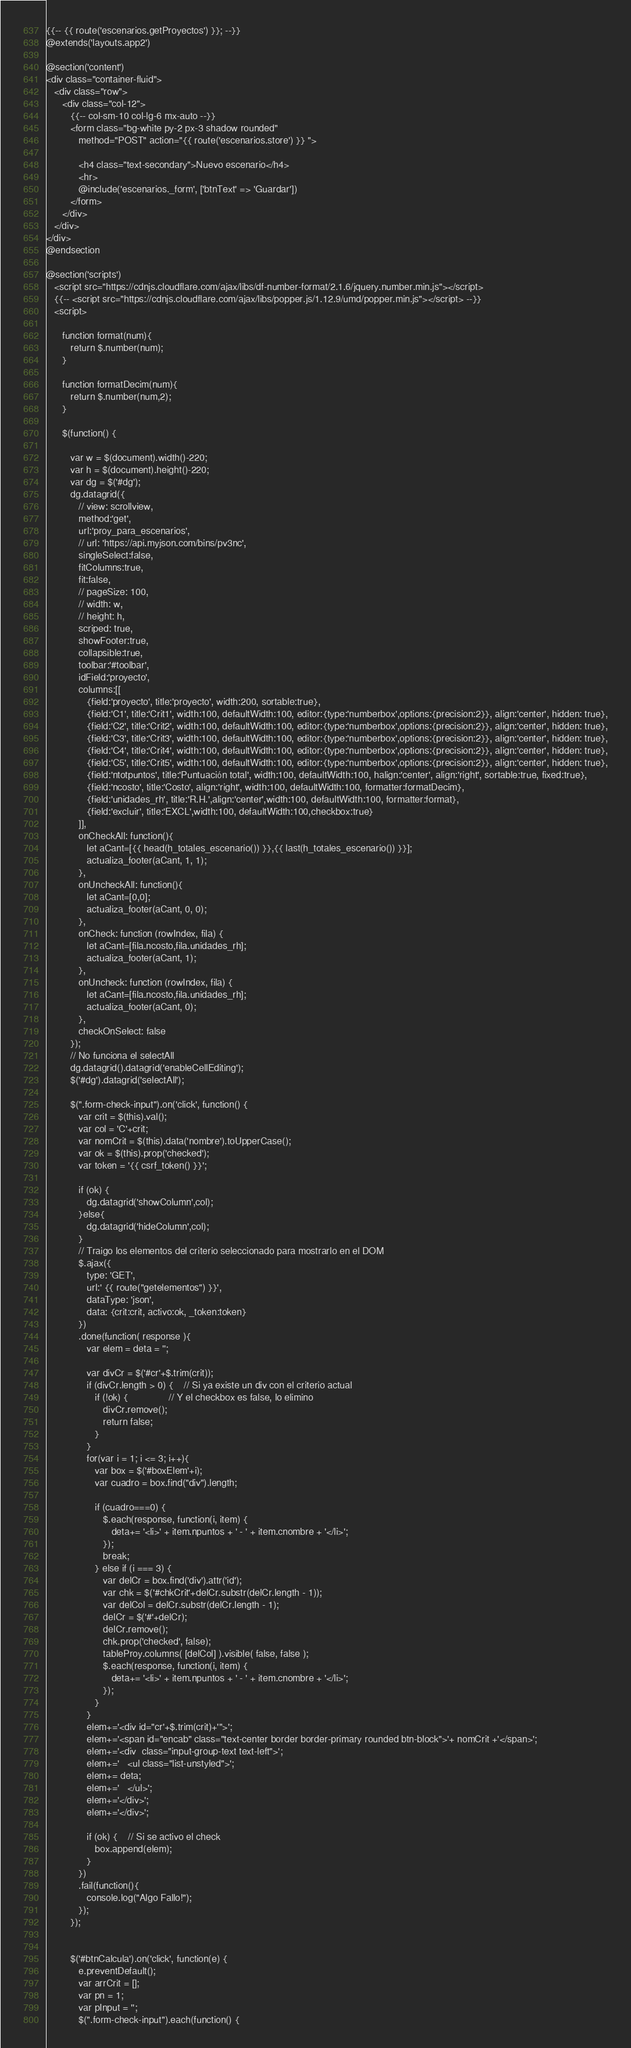Convert code to text. <code><loc_0><loc_0><loc_500><loc_500><_PHP_>{{-- {{ route('escenarios.getProyectos') }}; --}}
@extends('layouts.app2')

@section('content')
<div class="container-fluid">
   <div class="row">
      <div class="col-12">
         {{-- col-sm-10 col-lg-6 mx-auto --}}
         <form class="bg-white py-2 px-3 shadow rounded"
            method="POST" action="{{ route('escenarios.store') }} ">

            <h4 class="text-secondary">Nuevo escenario</h4>
            <hr>
            @include('escenarios._form', ['btnText' => 'Guardar'])
         </form>
      </div>
   </div>
</div>
@endsection

@section('scripts')
   <script src="https://cdnjs.cloudflare.com/ajax/libs/df-number-format/2.1.6/jquery.number.min.js"></script>
   {{-- <script src="https://cdnjs.cloudflare.com/ajax/libs/popper.js/1.12.9/umd/popper.min.js"></script> --}}
   <script>

      function format(num){
         return $.number(num);
      }

      function formatDecim(num){
         return $.number(num,2);
      }

      $(function() {

         var w = $(document).width()-220;
         var h = $(document).height()-220;
         var dg = $('#dg');
         dg.datagrid({
            // view: scrollview,
            method:'get',
            url:'proy_para_escenarios',
            // url: 'https://api.myjson.com/bins/pv3nc',
            singleSelect:false,
            fitColumns:true,
            fit:false,
            // pageSize: 100,
            // width: w,
            // height: h,
            scriped: true,
            showFooter:true,
            collapsible:true,
            toolbar:'#toolbar',
            idField:'proyecto',
            columns:[[
               {field:'proyecto', title:'proyecto', width:200, sortable:true},
               {field:'C1', title:'Crit1', width:100, defaultWidth:100, editor:{type:'numberbox',options:{precision:2}}, align:'center', hidden: true},
               {field:'C2', title:'Crit2', width:100, defaultWidth:100, editor:{type:'numberbox',options:{precision:2}}, align:'center', hidden: true},
               {field:'C3', title:'Crit3', width:100, defaultWidth:100, editor:{type:'numberbox',options:{precision:2}}, align:'center', hidden: true},
               {field:'C4', title:'Crit4', width:100, defaultWidth:100, editor:{type:'numberbox',options:{precision:2}}, align:'center', hidden: true},
               {field:'C5', title:'Crit5', width:100, defaultWidth:100, editor:{type:'numberbox',options:{precision:2}}, align:'center', hidden: true},
               {field:'ntotpuntos', title:'Puntuación total', width:100, defaultWidth:100, halign:'center', align:'right', sortable:true, fixed:true},
               {field:'ncosto', title:'Costo', align:'right', width:100, defaultWidth:100, formatter:formatDecim},
               {field:'unidades_rh', title:'R.H.',align:'center',width:100, defaultWidth:100, formatter:format},
               {field:'excluir', title:'EXCL',width:100, defaultWidth:100,checkbox:true}
            ]],
            onCheckAll: function(){
               let aCant=[{{ head(h_totales_escenario()) }},{{ last(h_totales_escenario()) }}];
               actualiza_footer(aCant, 1, 1);
            },
            onUncheckAll: function(){
               let aCant=[0,0];
               actualiza_footer(aCant, 0, 0);
            },
            onCheck: function (rowIndex, fila) {
               let aCant=[fila.ncosto,fila.unidades_rh];
               actualiza_footer(aCant, 1);
            },
            onUncheck: function (rowIndex, fila) {
               let aCant=[fila.ncosto,fila.unidades_rh];
               actualiza_footer(aCant, 0);
            },
            checkOnSelect: false
         });
         // No funciona el selectAll
         dg.datagrid().datagrid('enableCellEditing');
         $('#dg').datagrid('selectAll');

         $(".form-check-input").on('click', function() {
            var crit = $(this).val();
            var col = 'C'+crit;
            var nomCrit = $(this).data('nombre').toUpperCase();
            var ok = $(this).prop('checked');
            var token = '{{ csrf_token() }}';

            if (ok) {
               dg.datagrid('showColumn',col);
            }else{
               dg.datagrid('hideColumn',col);
            }
            // Traigo los elementos del criterio seleccionado para mostrarlo en el DOM
            $.ajax({
               type: 'GET',
               url:' {{ route("getelementos") }}',
               dataType: 'json',
               data: {crit:crit, activo:ok, _token:token}
            })
            .done(function( response ){
               var elem = deta = '';

               var divCr = $('#cr'+$.trim(crit));
               if (divCr.length > 0) {    // Si ya existe un div con el criterio actual
                  if (!ok) {               // Y el checkbox es false, lo elimino
                     divCr.remove();
                     return false;
                  }
               }
               for(var i = 1; i <= 3; i++){
                  var box = $('#boxElem'+i);
                  var cuadro = box.find("div").length;

                  if (cuadro===0) {
                     $.each(response, function(i, item) {
                        deta+= '<li>' + item.npuntos + ' - ' + item.cnombre + '</li>';
                     });
                     break;
                  } else if (i === 3) {
                     var delCr = box.find('div').attr('id');
                     var chk = $('#chkCrit'+delCr.substr(delCr.length - 1));
                     var delCol = delCr.substr(delCr.length - 1);
                     delCr = $('#'+delCr);
                     delCr.remove();
                     chk.prop('checked', false);
                     tableProy.columns( [delCol] ).visible( false, false );
                     $.each(response, function(i, item) {
                        deta+= '<li>' + item.npuntos + ' - ' + item.cnombre + '</li>';
                     });
                  }
               }
               elem+='<div id="cr'+$.trim(crit)+'">';
               elem+='<span id="encab" class="text-center border border-primary rounded btn-block">'+ nomCrit +'</span>';
               elem+='<div  class="input-group-text text-left">';
               elem+='   <ul class="list-unstyled">';
               elem+= deta;
               elem+='   </ul>';
               elem+='</div>';
               elem+='</div>';

               if (ok) {    // Si se activo el check
                  box.append(elem);
               }
            })
            .fail(function(){
               console.log("Algo Fallo!");
            });
         });


         $('#btnCalcula').on('click', function(e) {
            e.preventDefault();
            var arrCrit = [];
            var pn = 1;
            var pInput = '';
            $(".form-check-input").each(function() {</code> 